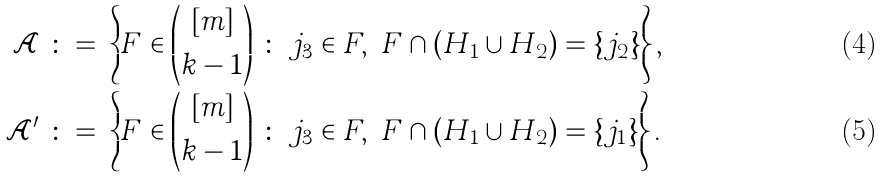<formula> <loc_0><loc_0><loc_500><loc_500>\mathcal { A } \ \colon = & \ \left \{ F \in { [ m ] \choose k - 1 } \ \colon \ j _ { 3 } \in F , \ F \cap ( H _ { 1 } \cup H _ { 2 } ) = \{ j _ { 2 } \} \right \} , \\ \mathcal { A } ^ { \prime } \ \colon = & \ \left \{ F \in { [ m ] \choose k - 1 } \ \colon \ j _ { 3 } \in F , \ F \cap ( H _ { 1 } \cup H _ { 2 } ) = \{ j _ { 1 } \} \right \} .</formula> 